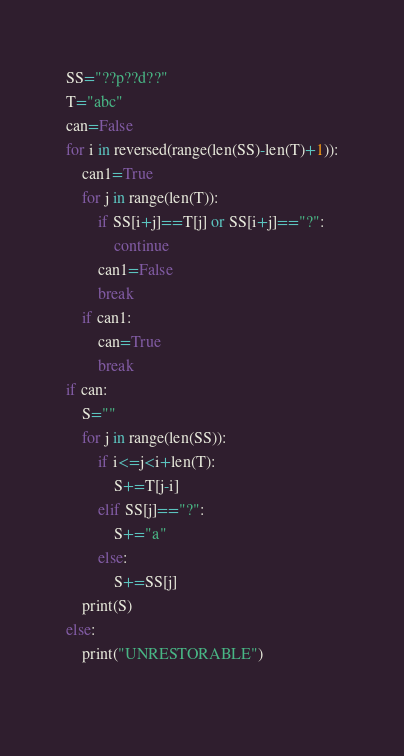Convert code to text. <code><loc_0><loc_0><loc_500><loc_500><_Python_>SS="??p??d??"
T="abc"
can=False
for i in reversed(range(len(SS)-len(T)+1)):
    can1=True
    for j in range(len(T)):
        if SS[i+j]==T[j] or SS[i+j]=="?":
            continue
        can1=False
        break
    if can1:
        can=True
        break
if can:
    S=""
    for j in range(len(SS)):
        if i<=j<i+len(T):
            S+=T[j-i]
        elif SS[j]=="?":
            S+="a"
        else:
            S+=SS[j]
    print(S)
else:
    print("UNRESTORABLE")
    </code> 